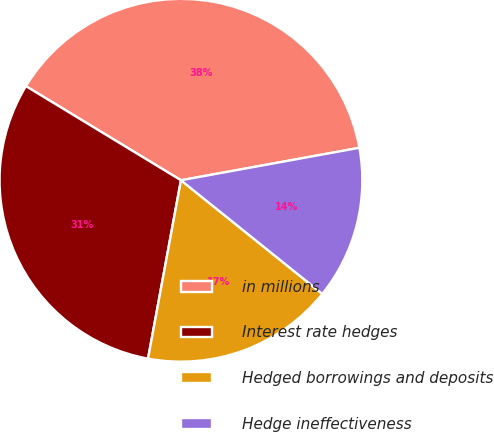Convert chart. <chart><loc_0><loc_0><loc_500><loc_500><pie_chart><fcel>in millions<fcel>Interest rate hedges<fcel>Hedged borrowings and deposits<fcel>Hedge ineffectiveness<nl><fcel>38.45%<fcel>30.78%<fcel>17.13%<fcel>13.64%<nl></chart> 